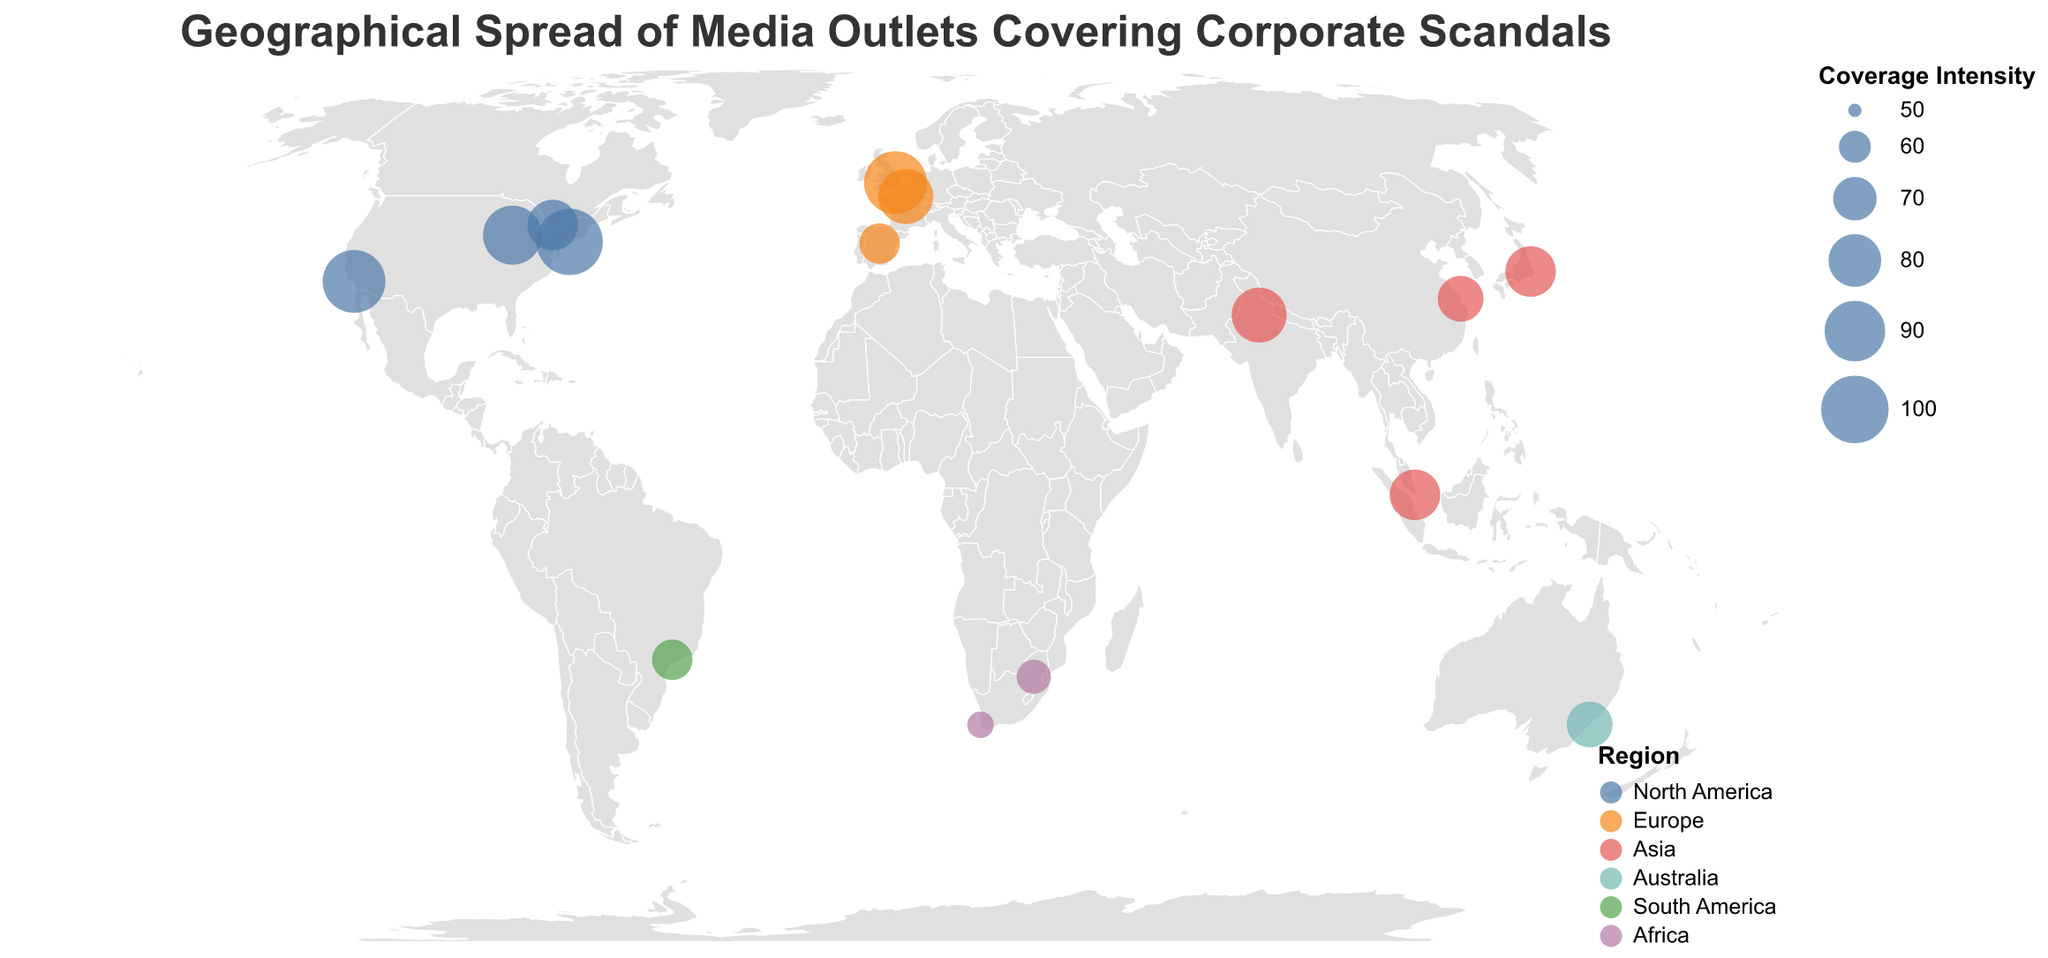What's the title of the figure? The title is generally found at the top of the figure, displaying prominently for easy visibility.
Answer: Geographical Spread of Media Outlets Covering Corporate Scandals How many media outlets are covering high-profile corporate scandals according to the figure? Count the number of circles on the map, as each circle represents a media outlet.
Answer: 15 Which media outlet has the highest coverage intensity? Locate the circle with the largest size, as size represents Coverage Intensity, then check the tooltip for its name.
Answer: The New York Times Which two continents have the fewest media outlets covering corporate scandals? Count the number of media outlets (circles) on each continent and compare; the two with the least are the answer.
Answer: Australia and South America How does the coverage intensity of BBC News compare to Le Monde? Hover over the circles representing BBC News and Le Monde to find their coverage intensities, then compare the two values.
Answer: BBC News has a higher coverage intensity (90 vs. 80) What is the average coverage intensity of media outlets in North America? Sum the coverage intensities of all North American media outlets and divide by the number of such outlets. (95 + 85 + 75 + 90) / 4 = 86.25
Answer: 86.25 Which region has the widest range of coverage intensities? Determine the difference between the maximum and minimum coverage intensities in each region, and identify the region with the largest range.
Answer: North America How many media outlets have a coverage intensity greater than 80? Count the circles representing media outlets with tooltip values for coverage intensities greater than 80.
Answer: 5 What is the coverage intensity of the Los Angeles Times? Find the Los Angeles Times circle and hover over it to check the coverage intensity in the tooltip.
Answer: 90 Which regions are represented by red and green colors? Check the legend to see which regions correspond to the red and green colors in the visual encoding.
Answer: Red represents Asia, Green represents South America 